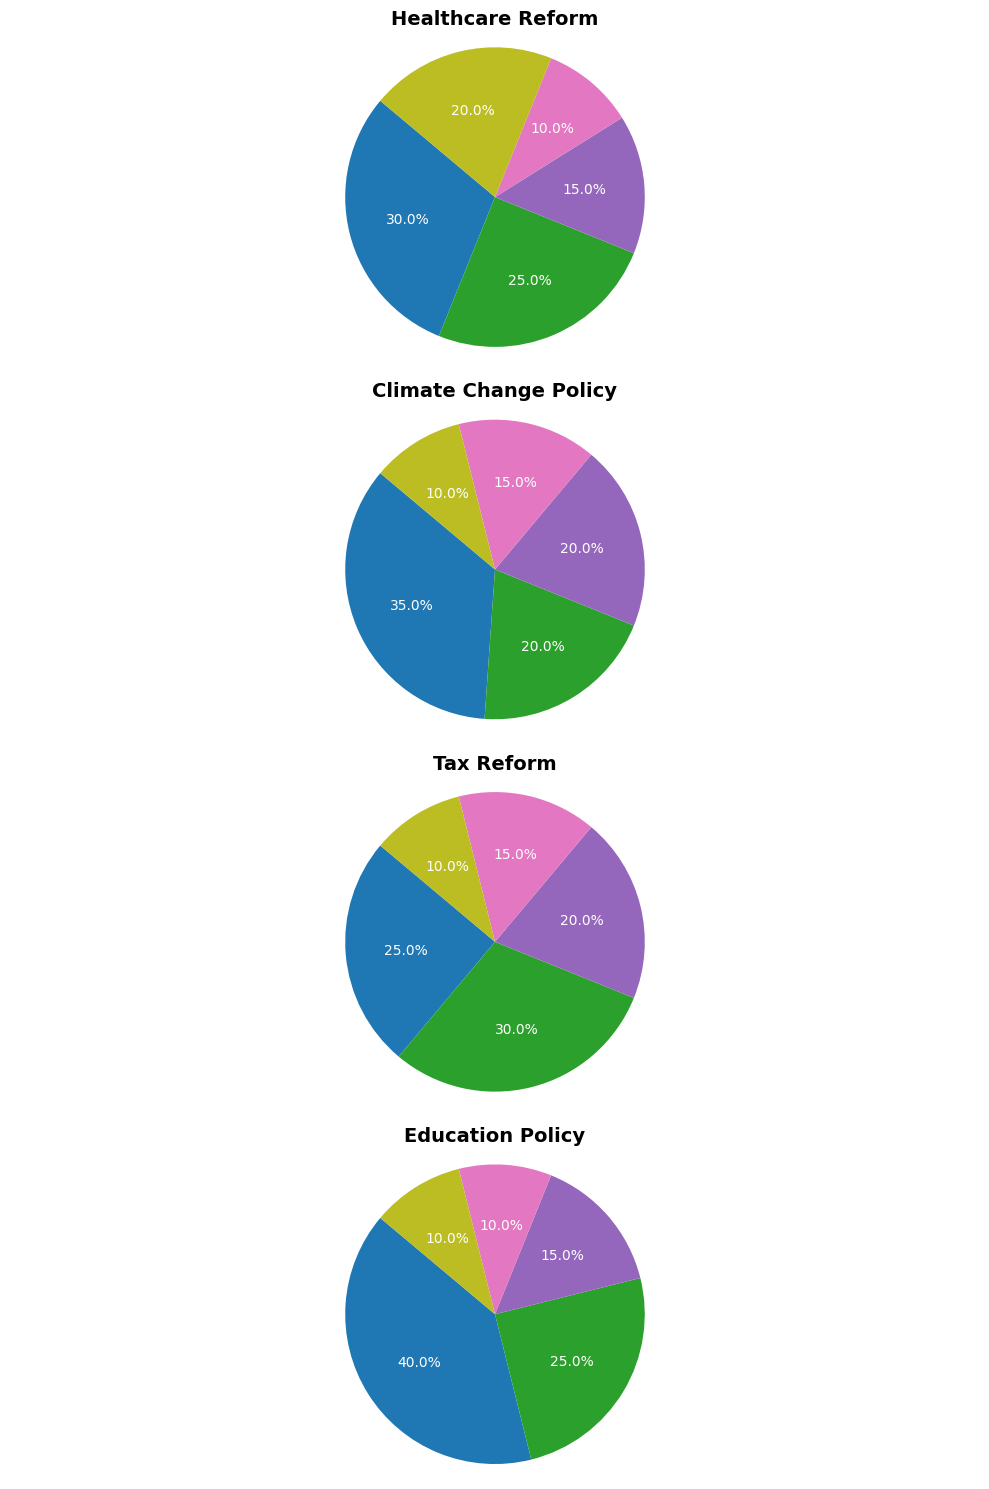Which policy has the highest percentage of neutral opinions? The figures show pie charts for each policy. Examine the 'neutral' segment in each pie chart and identify the one with the highest percentage.
Answer: Climate Change Policy Between Healthcare Reform and Education Policy, which one has more strong opposition? Compare the 'strongly oppose' segments from both the Healthcare Reform and Education Policy pie charts. The segment with the higher percentage indicates more strong opposition.
Answer: Healthcare Reform What is the combined percentage of somewhat and strongly support for Tax Reform? Add the 'somewhat support' (30%) and 'strongly support' (25%) segments for Tax Reform together.
Answer: 55% Is there any policy where the sum of all oppose levels equals 25%? Check each pie chart to find if any has the sum of 'somewhat oppose' and 'strongly oppose' levels equaling 25%.
Answer: No Which policy has a larger percentage of 'somewhat support', Climate Change Policy or Education Policy? Compare the 'somewhat support' segments of Climate Change Policy (20%) and Education Policy (25%). The segment with the higher percentage shows which policy has more 'somewhat support'.
Answer: Education Policy Considering all categories, which one shows the highest level of 'strongly support'? Look at the 'strongly support' segments across all pie charts and identify the one with the highest percentage.
Answer: Education Policy What is the difference in percentage points between 'strongly support' and 'strongly oppose' for Healthcare Reform? Subtract the 'strongly oppose' percentage (20%) from the 'strongly support' percentage (30%) for Healthcare Reform.
Answer: 10 What proportion of opinions on Education Policy are neutral? Identify the 'neutral' segment in the Education Policy pie chart and note the percentage.
Answer: 15% Among the policies, which has the lowest percentage of 'somewhat oppose'? Look at the 'somewhat oppose' segments for each policy and identify the lowest percentage.
Answer: Healthcare Reform Comparing the policies, which one shows more diversity in support levels, considering all categories combined? Evaluate the spread of percentages across support levels ('strongly support', 'somewhat support', 'neutral', 'somewhat oppose', 'strongly oppose') for each policy to determine which policy has the most diverse distribution.
Answer: Healthcare Reform 